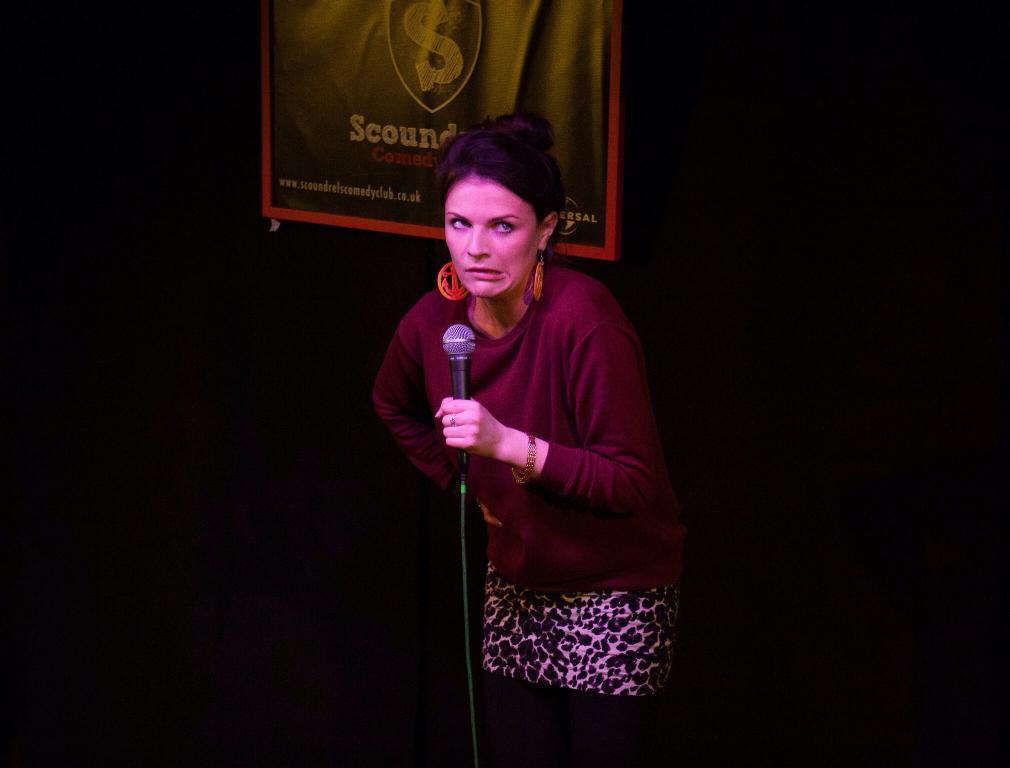Describe this image in one or two sentences. In the center of this picture there is a person wearing red color t-shirt, holding a microphone and standing. The background of the image is very dark and we can see a poster on which we can see the text is printed. 